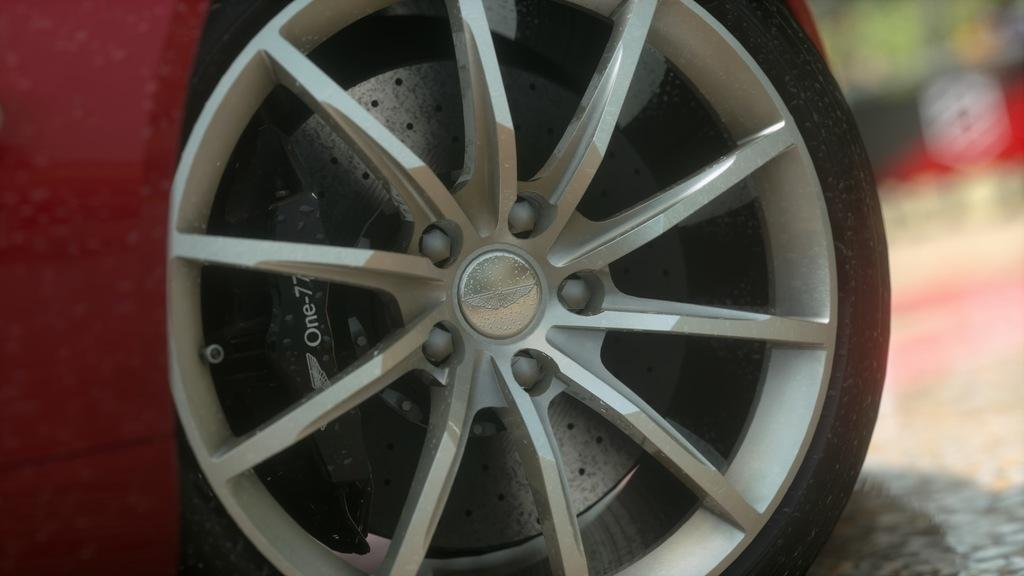What part of a vehicle can be seen in the image? There is a wheel of a vehicle in the image. What is the wheel made of? The wheel has a tire. How is the tire structured? The tire has spokes. What is the connection point for the spokes? The spokes are attached to a center hub. Can you describe the background of the image? The background of the image appears blurry. How does the card express regret in the image? There is no card or expression of regret present in the image. 